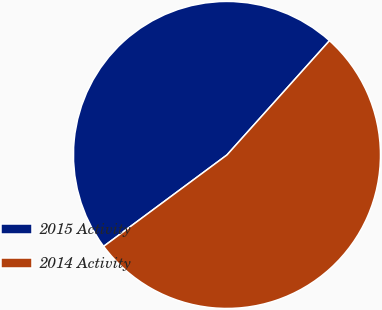<chart> <loc_0><loc_0><loc_500><loc_500><pie_chart><fcel>2015 Activity<fcel>2014 Activity<nl><fcel>46.79%<fcel>53.21%<nl></chart> 